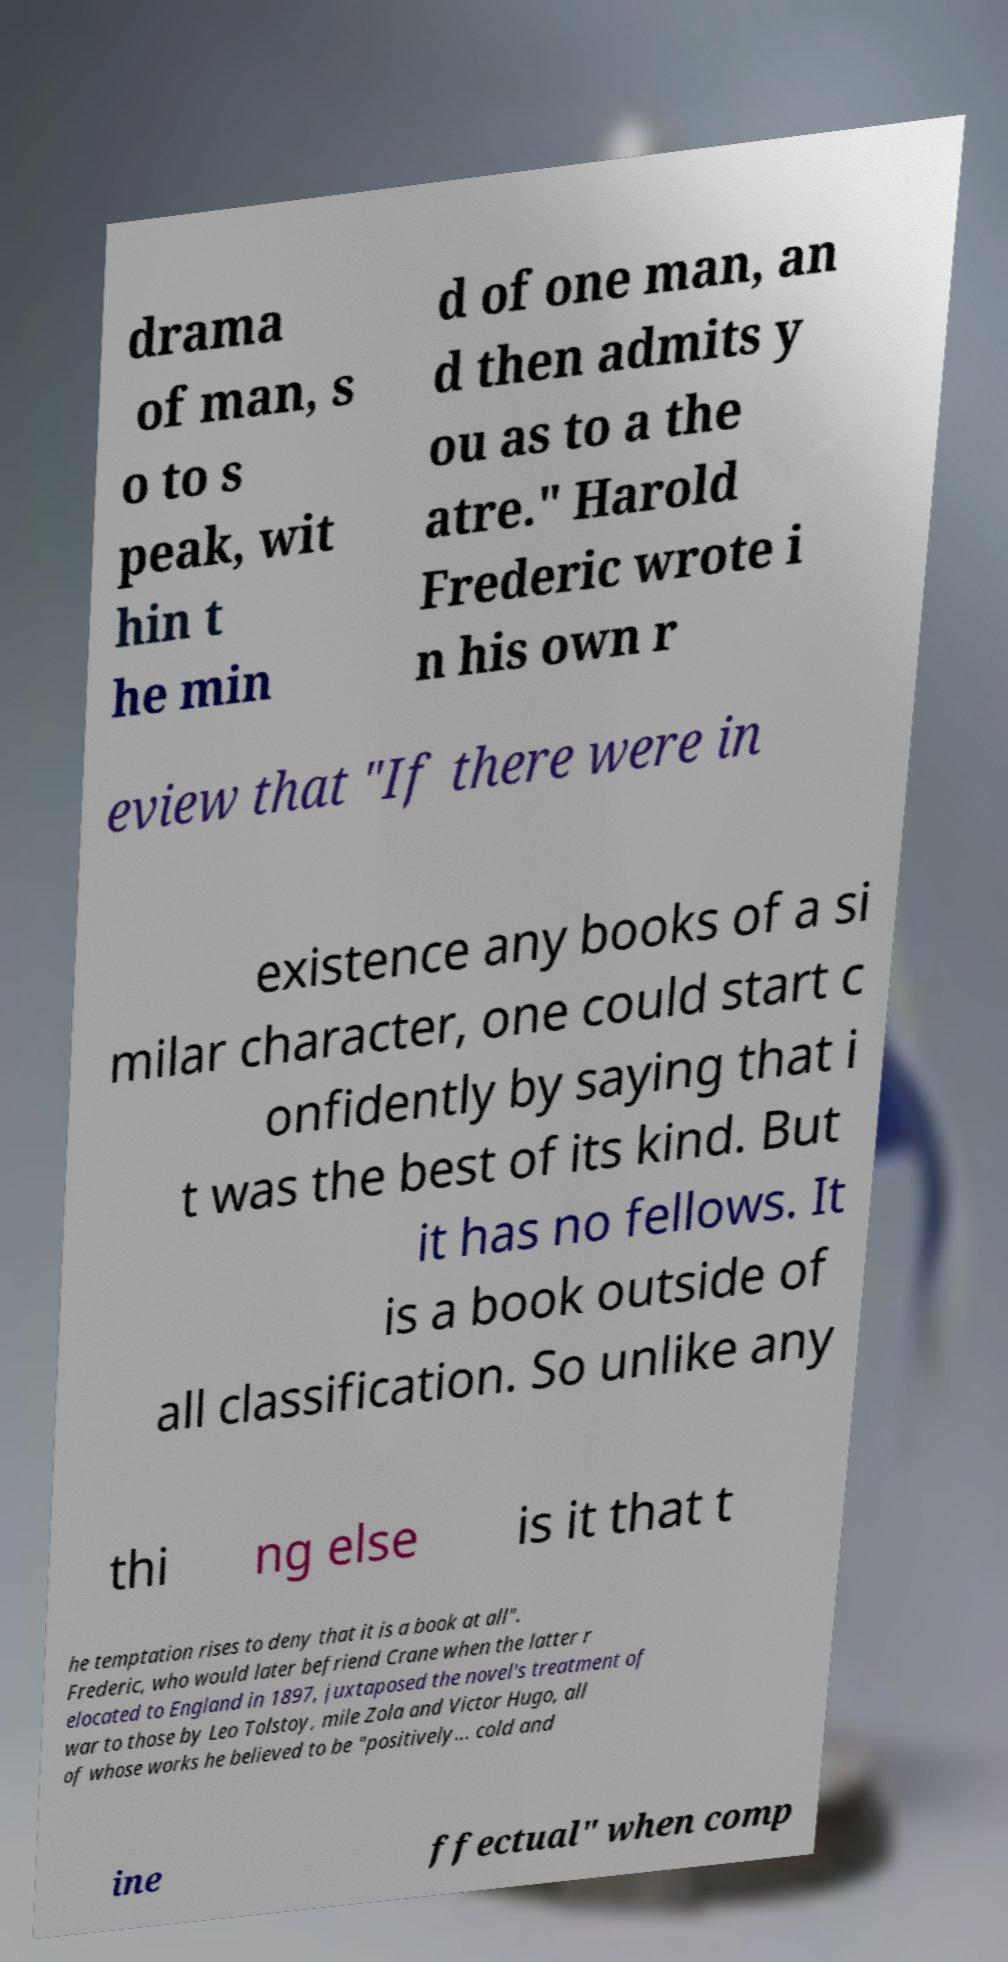Please read and relay the text visible in this image. What does it say? drama of man, s o to s peak, wit hin t he min d of one man, an d then admits y ou as to a the atre." Harold Frederic wrote i n his own r eview that "If there were in existence any books of a si milar character, one could start c onfidently by saying that i t was the best of its kind. But it has no fellows. It is a book outside of all classification. So unlike any thi ng else is it that t he temptation rises to deny that it is a book at all". Frederic, who would later befriend Crane when the latter r elocated to England in 1897, juxtaposed the novel's treatment of war to those by Leo Tolstoy, mile Zola and Victor Hugo, all of whose works he believed to be "positively... cold and ine ffectual" when comp 